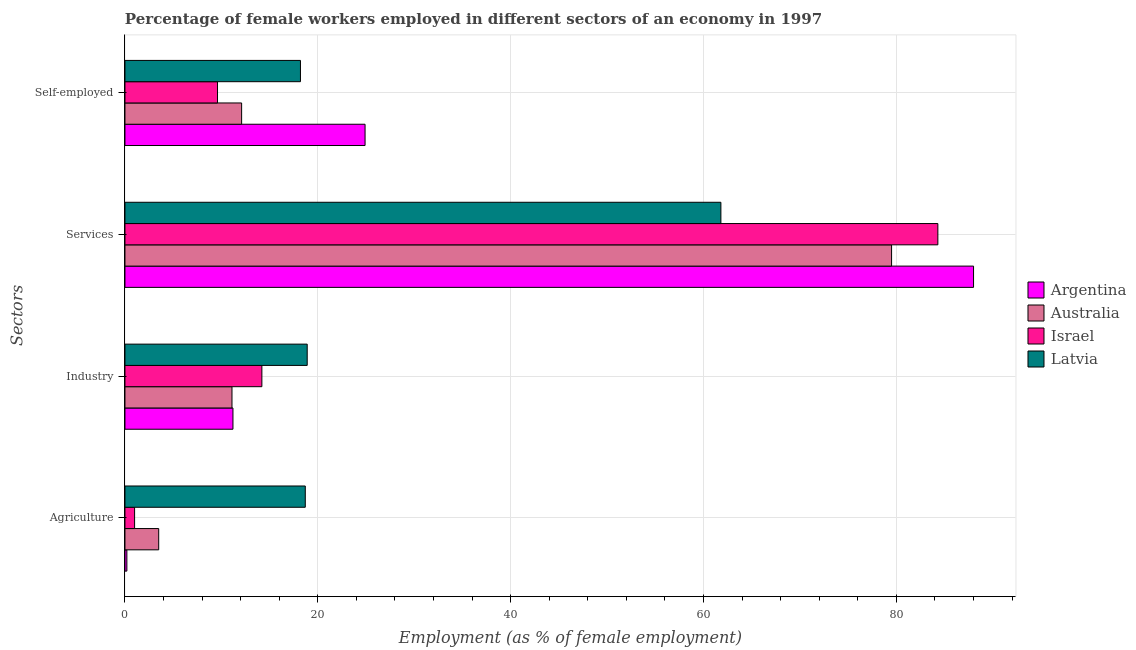Are the number of bars per tick equal to the number of legend labels?
Make the answer very short. Yes. What is the label of the 2nd group of bars from the top?
Keep it short and to the point. Services. What is the percentage of female workers in services in Israel?
Offer a terse response. 84.3. Across all countries, what is the maximum percentage of female workers in industry?
Give a very brief answer. 18.9. Across all countries, what is the minimum percentage of female workers in industry?
Keep it short and to the point. 11.1. In which country was the percentage of female workers in agriculture maximum?
Ensure brevity in your answer.  Latvia. What is the total percentage of self employed female workers in the graph?
Offer a terse response. 64.8. What is the difference between the percentage of female workers in industry in Israel and that in Argentina?
Offer a very short reply. 3. What is the difference between the percentage of self employed female workers in Israel and the percentage of female workers in agriculture in Argentina?
Your answer should be very brief. 9.4. What is the average percentage of female workers in services per country?
Your answer should be very brief. 78.4. What is the difference between the percentage of self employed female workers and percentage of female workers in services in Israel?
Offer a terse response. -74.7. In how many countries, is the percentage of female workers in industry greater than 80 %?
Keep it short and to the point. 0. What is the ratio of the percentage of self employed female workers in Argentina to that in Israel?
Give a very brief answer. 2.59. What is the difference between the highest and the second highest percentage of female workers in agriculture?
Your answer should be very brief. 15.2. What is the difference between the highest and the lowest percentage of female workers in services?
Your answer should be very brief. 26.2. Is the sum of the percentage of female workers in agriculture in Australia and Israel greater than the maximum percentage of female workers in industry across all countries?
Make the answer very short. No. What does the 2nd bar from the top in Services represents?
Offer a very short reply. Israel. How many bars are there?
Provide a succinct answer. 16. Are all the bars in the graph horizontal?
Provide a succinct answer. Yes. Are the values on the major ticks of X-axis written in scientific E-notation?
Offer a terse response. No. Where does the legend appear in the graph?
Ensure brevity in your answer.  Center right. What is the title of the graph?
Ensure brevity in your answer.  Percentage of female workers employed in different sectors of an economy in 1997. Does "Hong Kong" appear as one of the legend labels in the graph?
Make the answer very short. No. What is the label or title of the X-axis?
Provide a succinct answer. Employment (as % of female employment). What is the label or title of the Y-axis?
Give a very brief answer. Sectors. What is the Employment (as % of female employment) of Argentina in Agriculture?
Your response must be concise. 0.2. What is the Employment (as % of female employment) of Australia in Agriculture?
Give a very brief answer. 3.5. What is the Employment (as % of female employment) of Israel in Agriculture?
Offer a very short reply. 1. What is the Employment (as % of female employment) of Latvia in Agriculture?
Provide a short and direct response. 18.7. What is the Employment (as % of female employment) of Argentina in Industry?
Ensure brevity in your answer.  11.2. What is the Employment (as % of female employment) of Australia in Industry?
Give a very brief answer. 11.1. What is the Employment (as % of female employment) of Israel in Industry?
Make the answer very short. 14.2. What is the Employment (as % of female employment) in Latvia in Industry?
Offer a terse response. 18.9. What is the Employment (as % of female employment) in Argentina in Services?
Ensure brevity in your answer.  88. What is the Employment (as % of female employment) in Australia in Services?
Make the answer very short. 79.5. What is the Employment (as % of female employment) in Israel in Services?
Make the answer very short. 84.3. What is the Employment (as % of female employment) in Latvia in Services?
Provide a short and direct response. 61.8. What is the Employment (as % of female employment) in Argentina in Self-employed?
Offer a terse response. 24.9. What is the Employment (as % of female employment) of Australia in Self-employed?
Your response must be concise. 12.1. What is the Employment (as % of female employment) in Israel in Self-employed?
Your answer should be very brief. 9.6. What is the Employment (as % of female employment) of Latvia in Self-employed?
Keep it short and to the point. 18.2. Across all Sectors, what is the maximum Employment (as % of female employment) of Argentina?
Your answer should be very brief. 88. Across all Sectors, what is the maximum Employment (as % of female employment) of Australia?
Offer a terse response. 79.5. Across all Sectors, what is the maximum Employment (as % of female employment) of Israel?
Provide a succinct answer. 84.3. Across all Sectors, what is the maximum Employment (as % of female employment) of Latvia?
Offer a very short reply. 61.8. Across all Sectors, what is the minimum Employment (as % of female employment) in Argentina?
Make the answer very short. 0.2. Across all Sectors, what is the minimum Employment (as % of female employment) of Australia?
Keep it short and to the point. 3.5. Across all Sectors, what is the minimum Employment (as % of female employment) in Israel?
Provide a succinct answer. 1. Across all Sectors, what is the minimum Employment (as % of female employment) in Latvia?
Your answer should be very brief. 18.2. What is the total Employment (as % of female employment) in Argentina in the graph?
Your answer should be compact. 124.3. What is the total Employment (as % of female employment) in Australia in the graph?
Ensure brevity in your answer.  106.2. What is the total Employment (as % of female employment) in Israel in the graph?
Your answer should be very brief. 109.1. What is the total Employment (as % of female employment) in Latvia in the graph?
Keep it short and to the point. 117.6. What is the difference between the Employment (as % of female employment) in Argentina in Agriculture and that in Industry?
Ensure brevity in your answer.  -11. What is the difference between the Employment (as % of female employment) of Israel in Agriculture and that in Industry?
Offer a very short reply. -13.2. What is the difference between the Employment (as % of female employment) of Argentina in Agriculture and that in Services?
Keep it short and to the point. -87.8. What is the difference between the Employment (as % of female employment) in Australia in Agriculture and that in Services?
Keep it short and to the point. -76. What is the difference between the Employment (as % of female employment) in Israel in Agriculture and that in Services?
Give a very brief answer. -83.3. What is the difference between the Employment (as % of female employment) of Latvia in Agriculture and that in Services?
Offer a very short reply. -43.1. What is the difference between the Employment (as % of female employment) in Argentina in Agriculture and that in Self-employed?
Provide a short and direct response. -24.7. What is the difference between the Employment (as % of female employment) of Israel in Agriculture and that in Self-employed?
Offer a terse response. -8.6. What is the difference between the Employment (as % of female employment) of Latvia in Agriculture and that in Self-employed?
Give a very brief answer. 0.5. What is the difference between the Employment (as % of female employment) of Argentina in Industry and that in Services?
Give a very brief answer. -76.8. What is the difference between the Employment (as % of female employment) in Australia in Industry and that in Services?
Your answer should be very brief. -68.4. What is the difference between the Employment (as % of female employment) in Israel in Industry and that in Services?
Your response must be concise. -70.1. What is the difference between the Employment (as % of female employment) of Latvia in Industry and that in Services?
Provide a succinct answer. -42.9. What is the difference between the Employment (as % of female employment) of Argentina in Industry and that in Self-employed?
Make the answer very short. -13.7. What is the difference between the Employment (as % of female employment) in Argentina in Services and that in Self-employed?
Offer a terse response. 63.1. What is the difference between the Employment (as % of female employment) in Australia in Services and that in Self-employed?
Provide a succinct answer. 67.4. What is the difference between the Employment (as % of female employment) in Israel in Services and that in Self-employed?
Your response must be concise. 74.7. What is the difference between the Employment (as % of female employment) of Latvia in Services and that in Self-employed?
Your answer should be very brief. 43.6. What is the difference between the Employment (as % of female employment) in Argentina in Agriculture and the Employment (as % of female employment) in Australia in Industry?
Offer a terse response. -10.9. What is the difference between the Employment (as % of female employment) of Argentina in Agriculture and the Employment (as % of female employment) of Israel in Industry?
Offer a very short reply. -14. What is the difference between the Employment (as % of female employment) of Argentina in Agriculture and the Employment (as % of female employment) of Latvia in Industry?
Give a very brief answer. -18.7. What is the difference between the Employment (as % of female employment) in Australia in Agriculture and the Employment (as % of female employment) in Israel in Industry?
Offer a very short reply. -10.7. What is the difference between the Employment (as % of female employment) of Australia in Agriculture and the Employment (as % of female employment) of Latvia in Industry?
Offer a terse response. -15.4. What is the difference between the Employment (as % of female employment) of Israel in Agriculture and the Employment (as % of female employment) of Latvia in Industry?
Ensure brevity in your answer.  -17.9. What is the difference between the Employment (as % of female employment) in Argentina in Agriculture and the Employment (as % of female employment) in Australia in Services?
Your answer should be compact. -79.3. What is the difference between the Employment (as % of female employment) of Argentina in Agriculture and the Employment (as % of female employment) of Israel in Services?
Offer a terse response. -84.1. What is the difference between the Employment (as % of female employment) in Argentina in Agriculture and the Employment (as % of female employment) in Latvia in Services?
Offer a very short reply. -61.6. What is the difference between the Employment (as % of female employment) in Australia in Agriculture and the Employment (as % of female employment) in Israel in Services?
Ensure brevity in your answer.  -80.8. What is the difference between the Employment (as % of female employment) of Australia in Agriculture and the Employment (as % of female employment) of Latvia in Services?
Your answer should be compact. -58.3. What is the difference between the Employment (as % of female employment) of Israel in Agriculture and the Employment (as % of female employment) of Latvia in Services?
Your answer should be compact. -60.8. What is the difference between the Employment (as % of female employment) in Argentina in Agriculture and the Employment (as % of female employment) in Israel in Self-employed?
Make the answer very short. -9.4. What is the difference between the Employment (as % of female employment) in Australia in Agriculture and the Employment (as % of female employment) in Israel in Self-employed?
Your response must be concise. -6.1. What is the difference between the Employment (as % of female employment) in Australia in Agriculture and the Employment (as % of female employment) in Latvia in Self-employed?
Your answer should be very brief. -14.7. What is the difference between the Employment (as % of female employment) of Israel in Agriculture and the Employment (as % of female employment) of Latvia in Self-employed?
Offer a very short reply. -17.2. What is the difference between the Employment (as % of female employment) of Argentina in Industry and the Employment (as % of female employment) of Australia in Services?
Offer a very short reply. -68.3. What is the difference between the Employment (as % of female employment) in Argentina in Industry and the Employment (as % of female employment) in Israel in Services?
Offer a terse response. -73.1. What is the difference between the Employment (as % of female employment) in Argentina in Industry and the Employment (as % of female employment) in Latvia in Services?
Give a very brief answer. -50.6. What is the difference between the Employment (as % of female employment) in Australia in Industry and the Employment (as % of female employment) in Israel in Services?
Keep it short and to the point. -73.2. What is the difference between the Employment (as % of female employment) of Australia in Industry and the Employment (as % of female employment) of Latvia in Services?
Ensure brevity in your answer.  -50.7. What is the difference between the Employment (as % of female employment) in Israel in Industry and the Employment (as % of female employment) in Latvia in Services?
Ensure brevity in your answer.  -47.6. What is the difference between the Employment (as % of female employment) of Argentina in Industry and the Employment (as % of female employment) of Australia in Self-employed?
Give a very brief answer. -0.9. What is the difference between the Employment (as % of female employment) in Australia in Industry and the Employment (as % of female employment) in Israel in Self-employed?
Your answer should be compact. 1.5. What is the difference between the Employment (as % of female employment) of Israel in Industry and the Employment (as % of female employment) of Latvia in Self-employed?
Your answer should be compact. -4. What is the difference between the Employment (as % of female employment) of Argentina in Services and the Employment (as % of female employment) of Australia in Self-employed?
Provide a succinct answer. 75.9. What is the difference between the Employment (as % of female employment) in Argentina in Services and the Employment (as % of female employment) in Israel in Self-employed?
Offer a very short reply. 78.4. What is the difference between the Employment (as % of female employment) of Argentina in Services and the Employment (as % of female employment) of Latvia in Self-employed?
Provide a short and direct response. 69.8. What is the difference between the Employment (as % of female employment) in Australia in Services and the Employment (as % of female employment) in Israel in Self-employed?
Provide a succinct answer. 69.9. What is the difference between the Employment (as % of female employment) of Australia in Services and the Employment (as % of female employment) of Latvia in Self-employed?
Your answer should be very brief. 61.3. What is the difference between the Employment (as % of female employment) of Israel in Services and the Employment (as % of female employment) of Latvia in Self-employed?
Give a very brief answer. 66.1. What is the average Employment (as % of female employment) in Argentina per Sectors?
Your answer should be very brief. 31.07. What is the average Employment (as % of female employment) of Australia per Sectors?
Provide a succinct answer. 26.55. What is the average Employment (as % of female employment) in Israel per Sectors?
Your answer should be very brief. 27.27. What is the average Employment (as % of female employment) of Latvia per Sectors?
Make the answer very short. 29.4. What is the difference between the Employment (as % of female employment) of Argentina and Employment (as % of female employment) of Latvia in Agriculture?
Offer a terse response. -18.5. What is the difference between the Employment (as % of female employment) in Australia and Employment (as % of female employment) in Latvia in Agriculture?
Keep it short and to the point. -15.2. What is the difference between the Employment (as % of female employment) in Israel and Employment (as % of female employment) in Latvia in Agriculture?
Offer a terse response. -17.7. What is the difference between the Employment (as % of female employment) of Argentina and Employment (as % of female employment) of Australia in Industry?
Give a very brief answer. 0.1. What is the difference between the Employment (as % of female employment) in Argentina and Employment (as % of female employment) in Israel in Industry?
Make the answer very short. -3. What is the difference between the Employment (as % of female employment) of Australia and Employment (as % of female employment) of Latvia in Industry?
Your response must be concise. -7.8. What is the difference between the Employment (as % of female employment) in Argentina and Employment (as % of female employment) in Latvia in Services?
Your answer should be compact. 26.2. What is the difference between the Employment (as % of female employment) in Israel and Employment (as % of female employment) in Latvia in Services?
Make the answer very short. 22.5. What is the difference between the Employment (as % of female employment) in Argentina and Employment (as % of female employment) in Australia in Self-employed?
Ensure brevity in your answer.  12.8. What is the difference between the Employment (as % of female employment) of Australia and Employment (as % of female employment) of Latvia in Self-employed?
Give a very brief answer. -6.1. What is the difference between the Employment (as % of female employment) in Israel and Employment (as % of female employment) in Latvia in Self-employed?
Provide a short and direct response. -8.6. What is the ratio of the Employment (as % of female employment) of Argentina in Agriculture to that in Industry?
Offer a very short reply. 0.02. What is the ratio of the Employment (as % of female employment) of Australia in Agriculture to that in Industry?
Keep it short and to the point. 0.32. What is the ratio of the Employment (as % of female employment) of Israel in Agriculture to that in Industry?
Make the answer very short. 0.07. What is the ratio of the Employment (as % of female employment) in Argentina in Agriculture to that in Services?
Ensure brevity in your answer.  0. What is the ratio of the Employment (as % of female employment) of Australia in Agriculture to that in Services?
Your answer should be compact. 0.04. What is the ratio of the Employment (as % of female employment) of Israel in Agriculture to that in Services?
Your response must be concise. 0.01. What is the ratio of the Employment (as % of female employment) in Latvia in Agriculture to that in Services?
Provide a succinct answer. 0.3. What is the ratio of the Employment (as % of female employment) in Argentina in Agriculture to that in Self-employed?
Offer a terse response. 0.01. What is the ratio of the Employment (as % of female employment) of Australia in Agriculture to that in Self-employed?
Your answer should be very brief. 0.29. What is the ratio of the Employment (as % of female employment) in Israel in Agriculture to that in Self-employed?
Ensure brevity in your answer.  0.1. What is the ratio of the Employment (as % of female employment) in Latvia in Agriculture to that in Self-employed?
Your answer should be very brief. 1.03. What is the ratio of the Employment (as % of female employment) of Argentina in Industry to that in Services?
Ensure brevity in your answer.  0.13. What is the ratio of the Employment (as % of female employment) of Australia in Industry to that in Services?
Keep it short and to the point. 0.14. What is the ratio of the Employment (as % of female employment) of Israel in Industry to that in Services?
Provide a succinct answer. 0.17. What is the ratio of the Employment (as % of female employment) in Latvia in Industry to that in Services?
Provide a short and direct response. 0.31. What is the ratio of the Employment (as % of female employment) in Argentina in Industry to that in Self-employed?
Offer a very short reply. 0.45. What is the ratio of the Employment (as % of female employment) of Australia in Industry to that in Self-employed?
Offer a terse response. 0.92. What is the ratio of the Employment (as % of female employment) in Israel in Industry to that in Self-employed?
Your answer should be compact. 1.48. What is the ratio of the Employment (as % of female employment) in Latvia in Industry to that in Self-employed?
Offer a very short reply. 1.04. What is the ratio of the Employment (as % of female employment) of Argentina in Services to that in Self-employed?
Give a very brief answer. 3.53. What is the ratio of the Employment (as % of female employment) of Australia in Services to that in Self-employed?
Keep it short and to the point. 6.57. What is the ratio of the Employment (as % of female employment) in Israel in Services to that in Self-employed?
Your answer should be very brief. 8.78. What is the ratio of the Employment (as % of female employment) in Latvia in Services to that in Self-employed?
Keep it short and to the point. 3.4. What is the difference between the highest and the second highest Employment (as % of female employment) of Argentina?
Keep it short and to the point. 63.1. What is the difference between the highest and the second highest Employment (as % of female employment) of Australia?
Your answer should be compact. 67.4. What is the difference between the highest and the second highest Employment (as % of female employment) in Israel?
Your answer should be compact. 70.1. What is the difference between the highest and the second highest Employment (as % of female employment) of Latvia?
Your answer should be very brief. 42.9. What is the difference between the highest and the lowest Employment (as % of female employment) of Argentina?
Offer a terse response. 87.8. What is the difference between the highest and the lowest Employment (as % of female employment) of Israel?
Give a very brief answer. 83.3. What is the difference between the highest and the lowest Employment (as % of female employment) in Latvia?
Provide a short and direct response. 43.6. 